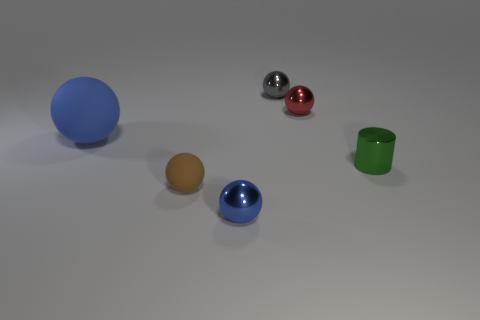Is the shape of the red thing the same as the tiny blue metallic object?
Your answer should be compact. Yes. What size is the blue shiny object that is the same shape as the red metal thing?
Your response must be concise. Small. Do the ball behind the red metallic ball and the brown thing have the same size?
Provide a short and direct response. Yes. What size is the thing that is in front of the blue matte object and left of the small blue sphere?
Keep it short and to the point. Small. There is a tiny ball that is the same color as the big object; what is it made of?
Keep it short and to the point. Metal. What number of large rubber balls have the same color as the small matte ball?
Your answer should be compact. 0. Are there an equal number of large matte things that are behind the big blue sphere and shiny balls?
Offer a very short reply. No. The small rubber ball is what color?
Give a very brief answer. Brown. What size is the cylinder that is the same material as the red thing?
Offer a terse response. Small. There is a sphere that is made of the same material as the tiny brown thing; what is its color?
Offer a terse response. Blue. 